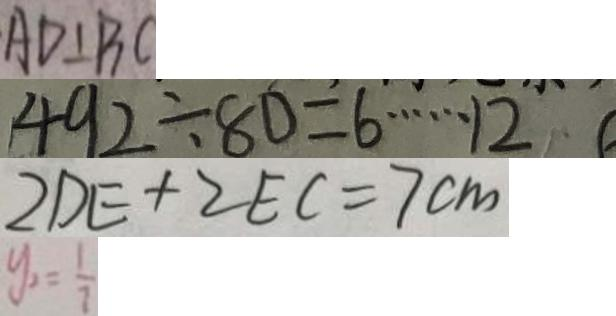Convert formula to latex. <formula><loc_0><loc_0><loc_500><loc_500>A D \bot B C 
 4 9 2 \div 8 0 = 6 \cdots 1 2 
 2 D E + 2 E C = 7 c m 
 y _ { 2 } = \frac { 1 } { 7 }</formula> 